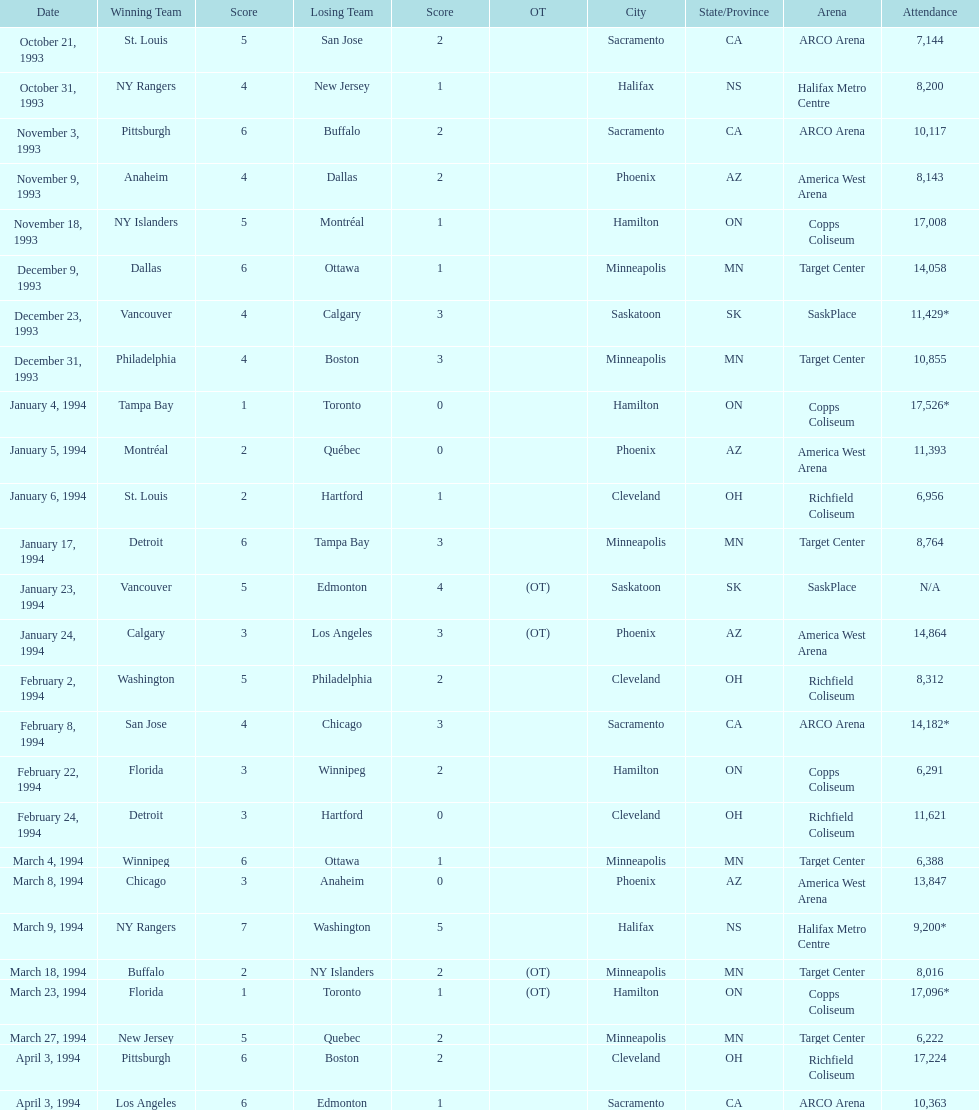On january 24, 1994, how many people attended? 14,864. On december 23, 1993, what was the number of attendees? 11,429*. Which date had more attendees between january 24, 1994, and december 23, 1993? January 4, 1994. 